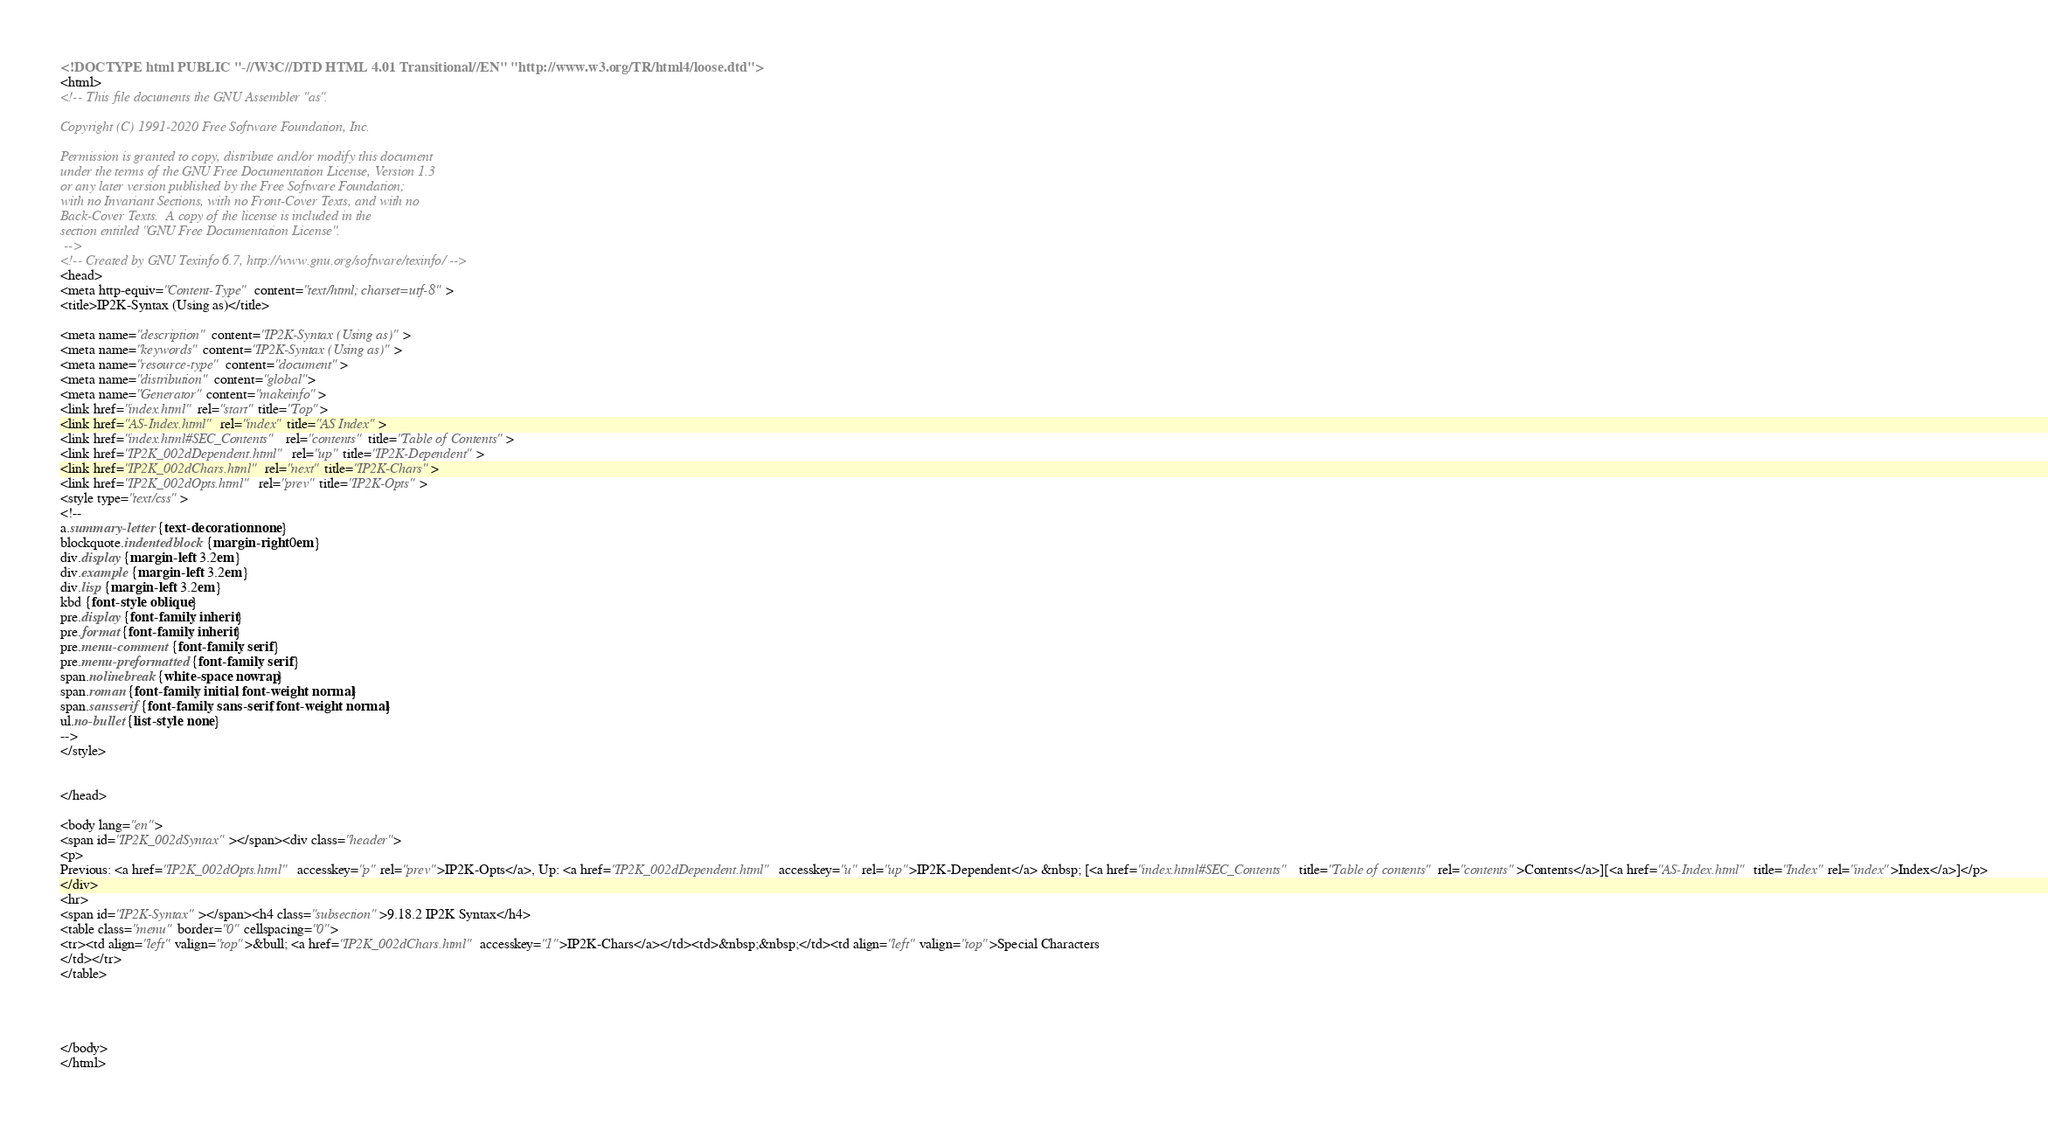<code> <loc_0><loc_0><loc_500><loc_500><_HTML_><!DOCTYPE html PUBLIC "-//W3C//DTD HTML 4.01 Transitional//EN" "http://www.w3.org/TR/html4/loose.dtd">
<html>
<!-- This file documents the GNU Assembler "as".

Copyright (C) 1991-2020 Free Software Foundation, Inc.

Permission is granted to copy, distribute and/or modify this document
under the terms of the GNU Free Documentation License, Version 1.3
or any later version published by the Free Software Foundation;
with no Invariant Sections, with no Front-Cover Texts, and with no
Back-Cover Texts.  A copy of the license is included in the
section entitled "GNU Free Documentation License".
 -->
<!-- Created by GNU Texinfo 6.7, http://www.gnu.org/software/texinfo/ -->
<head>
<meta http-equiv="Content-Type" content="text/html; charset=utf-8">
<title>IP2K-Syntax (Using as)</title>

<meta name="description" content="IP2K-Syntax (Using as)">
<meta name="keywords" content="IP2K-Syntax (Using as)">
<meta name="resource-type" content="document">
<meta name="distribution" content="global">
<meta name="Generator" content="makeinfo">
<link href="index.html" rel="start" title="Top">
<link href="AS-Index.html" rel="index" title="AS Index">
<link href="index.html#SEC_Contents" rel="contents" title="Table of Contents">
<link href="IP2K_002dDependent.html" rel="up" title="IP2K-Dependent">
<link href="IP2K_002dChars.html" rel="next" title="IP2K-Chars">
<link href="IP2K_002dOpts.html" rel="prev" title="IP2K-Opts">
<style type="text/css">
<!--
a.summary-letter {text-decoration: none}
blockquote.indentedblock {margin-right: 0em}
div.display {margin-left: 3.2em}
div.example {margin-left: 3.2em}
div.lisp {margin-left: 3.2em}
kbd {font-style: oblique}
pre.display {font-family: inherit}
pre.format {font-family: inherit}
pre.menu-comment {font-family: serif}
pre.menu-preformatted {font-family: serif}
span.nolinebreak {white-space: nowrap}
span.roman {font-family: initial; font-weight: normal}
span.sansserif {font-family: sans-serif; font-weight: normal}
ul.no-bullet {list-style: none}
-->
</style>


</head>

<body lang="en">
<span id="IP2K_002dSyntax"></span><div class="header">
<p>
Previous: <a href="IP2K_002dOpts.html" accesskey="p" rel="prev">IP2K-Opts</a>, Up: <a href="IP2K_002dDependent.html" accesskey="u" rel="up">IP2K-Dependent</a> &nbsp; [<a href="index.html#SEC_Contents" title="Table of contents" rel="contents">Contents</a>][<a href="AS-Index.html" title="Index" rel="index">Index</a>]</p>
</div>
<hr>
<span id="IP2K-Syntax"></span><h4 class="subsection">9.18.2 IP2K Syntax</h4>
<table class="menu" border="0" cellspacing="0">
<tr><td align="left" valign="top">&bull; <a href="IP2K_002dChars.html" accesskey="1">IP2K-Chars</a></td><td>&nbsp;&nbsp;</td><td align="left" valign="top">Special Characters
</td></tr>
</table>




</body>
</html>
</code> 